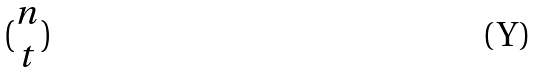Convert formula to latex. <formula><loc_0><loc_0><loc_500><loc_500>( \begin{matrix} n \\ t \end{matrix} )</formula> 